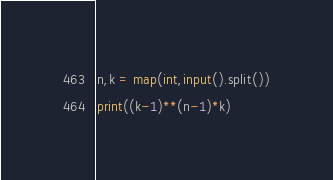Convert code to text. <code><loc_0><loc_0><loc_500><loc_500><_Python_>n,k = map(int,input().split())
print((k-1)**(n-1)*k)</code> 